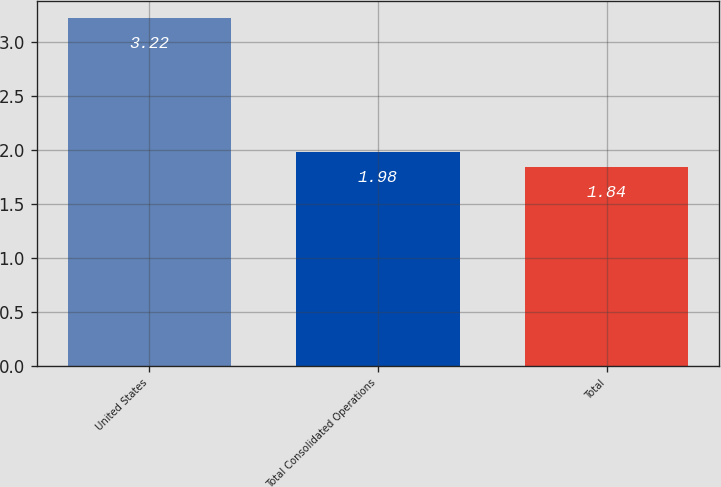<chart> <loc_0><loc_0><loc_500><loc_500><bar_chart><fcel>United States<fcel>Total Consolidated Operations<fcel>Total<nl><fcel>3.22<fcel>1.98<fcel>1.84<nl></chart> 